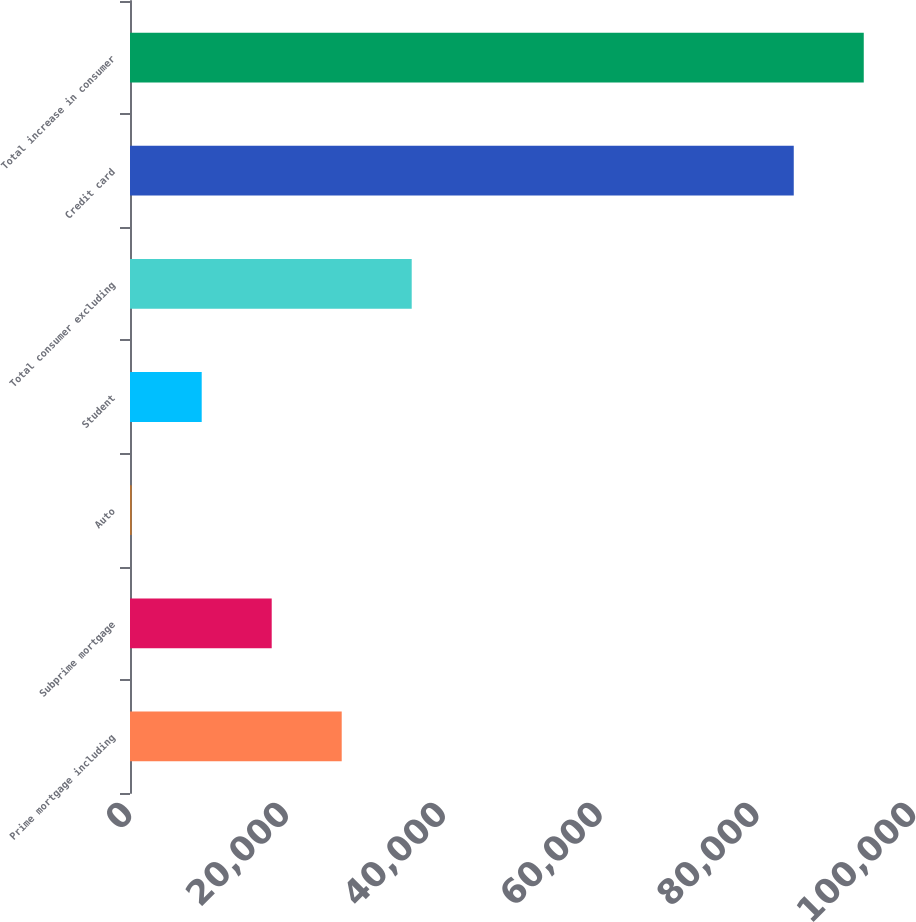<chart> <loc_0><loc_0><loc_500><loc_500><bar_chart><fcel>Prime mortgage including<fcel>Subprime mortgage<fcel>Auto<fcel>Student<fcel>Total consumer excluding<fcel>Credit card<fcel>Total increase in consumer<nl><fcel>27004.1<fcel>18075.4<fcel>218<fcel>9146.7<fcel>35932.8<fcel>84663<fcel>93591.7<nl></chart> 